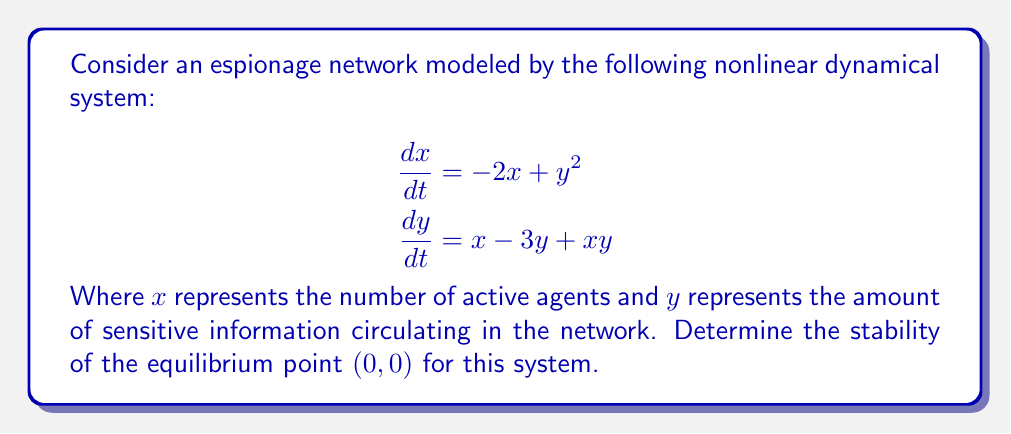Can you solve this math problem? To analyze the stability of the equilibrium point $(0,0)$, we'll follow these steps:

1) First, we need to find the Jacobian matrix of the system at the equilibrium point:

   $$J(x,y) = \begin{bmatrix}
   \frac{\partial f_1}{\partial x} & \frac{\partial f_1}{\partial y} \\
   \frac{\partial f_2}{\partial x} & \frac{\partial f_2}{\partial y}
   \end{bmatrix} = \begin{bmatrix}
   -2 & 2y \\
   1+y & -3+x
   \end{bmatrix}$$

2) Evaluate the Jacobian at the equilibrium point $(0,0)$:

   $$J(0,0) = \begin{bmatrix}
   -2 & 0 \\
   1 & -3
   \end{bmatrix}$$

3) Calculate the eigenvalues of $J(0,0)$ by solving the characteristic equation:

   $$\det(J(0,0) - \lambda I) = 0$$
   $$\begin{vmatrix}
   -2-\lambda & 0 \\
   1 & -3-\lambda
   \end{vmatrix} = 0$$
   $$(-2-\lambda)(-3-\lambda) = 0$$

4) Solve for $\lambda$:
   
   $\lambda_1 = -2$ and $\lambda_2 = -3$

5) Since both eigenvalues are real and negative, the equilibrium point $(0,0)$ is asymptotically stable.

This means that small perturbations in the number of active agents or the amount of sensitive information will eventually return to the equilibrium state, indicating a self-regulating espionage network.
Answer: Asymptotically stable 